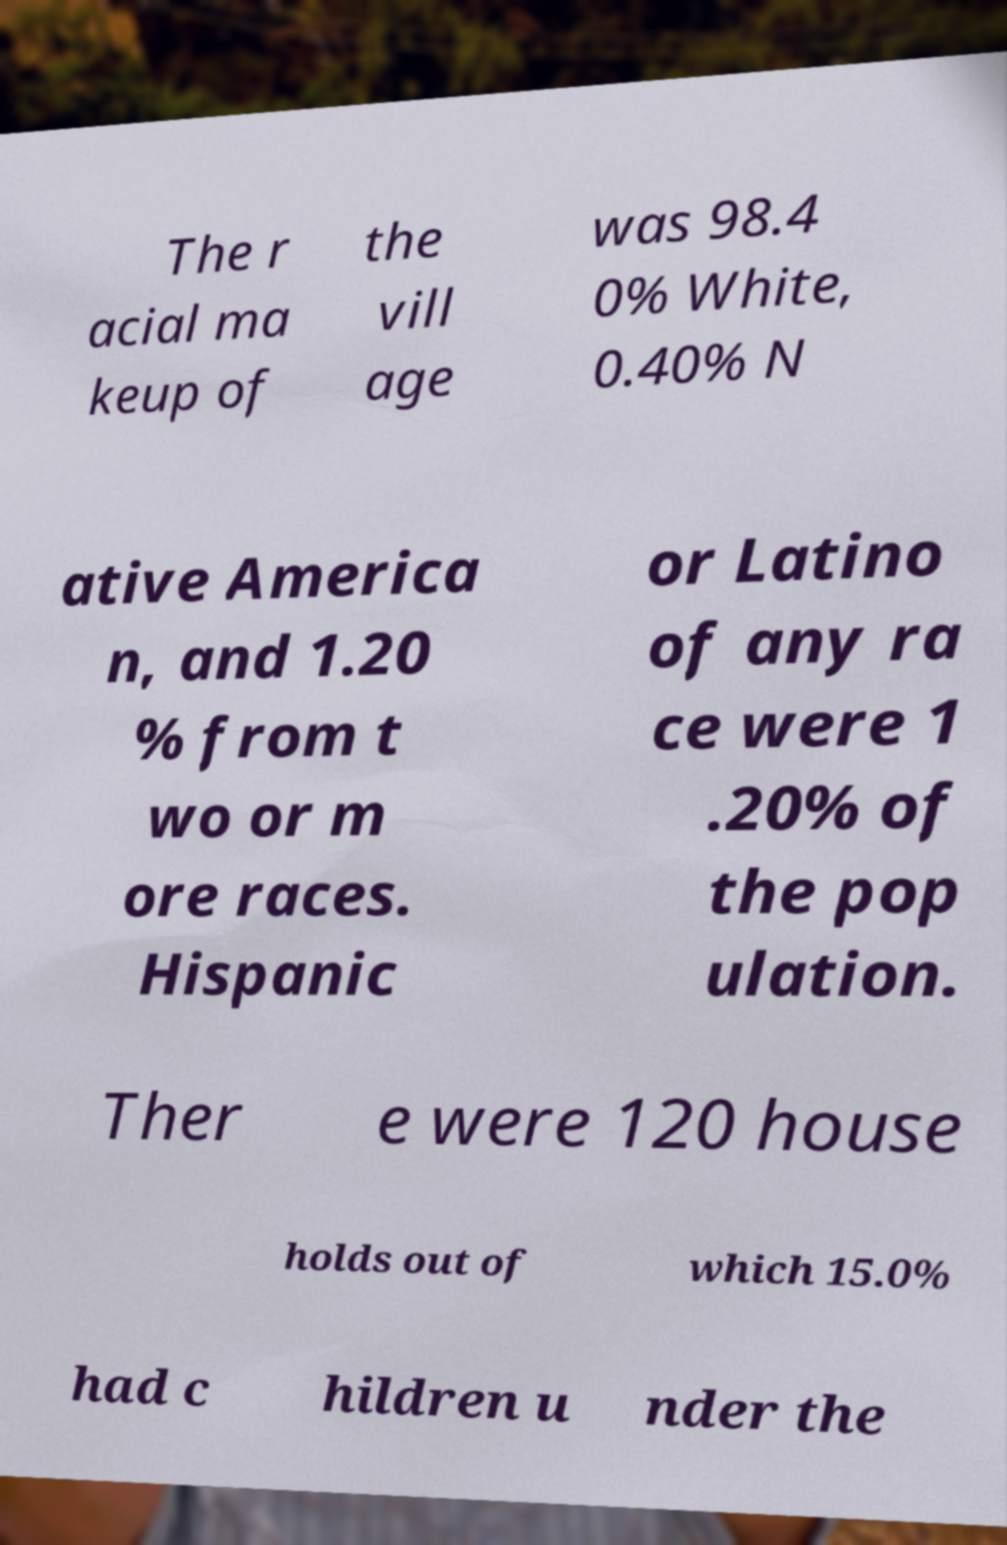For documentation purposes, I need the text within this image transcribed. Could you provide that? The r acial ma keup of the vill age was 98.4 0% White, 0.40% N ative America n, and 1.20 % from t wo or m ore races. Hispanic or Latino of any ra ce were 1 .20% of the pop ulation. Ther e were 120 house holds out of which 15.0% had c hildren u nder the 